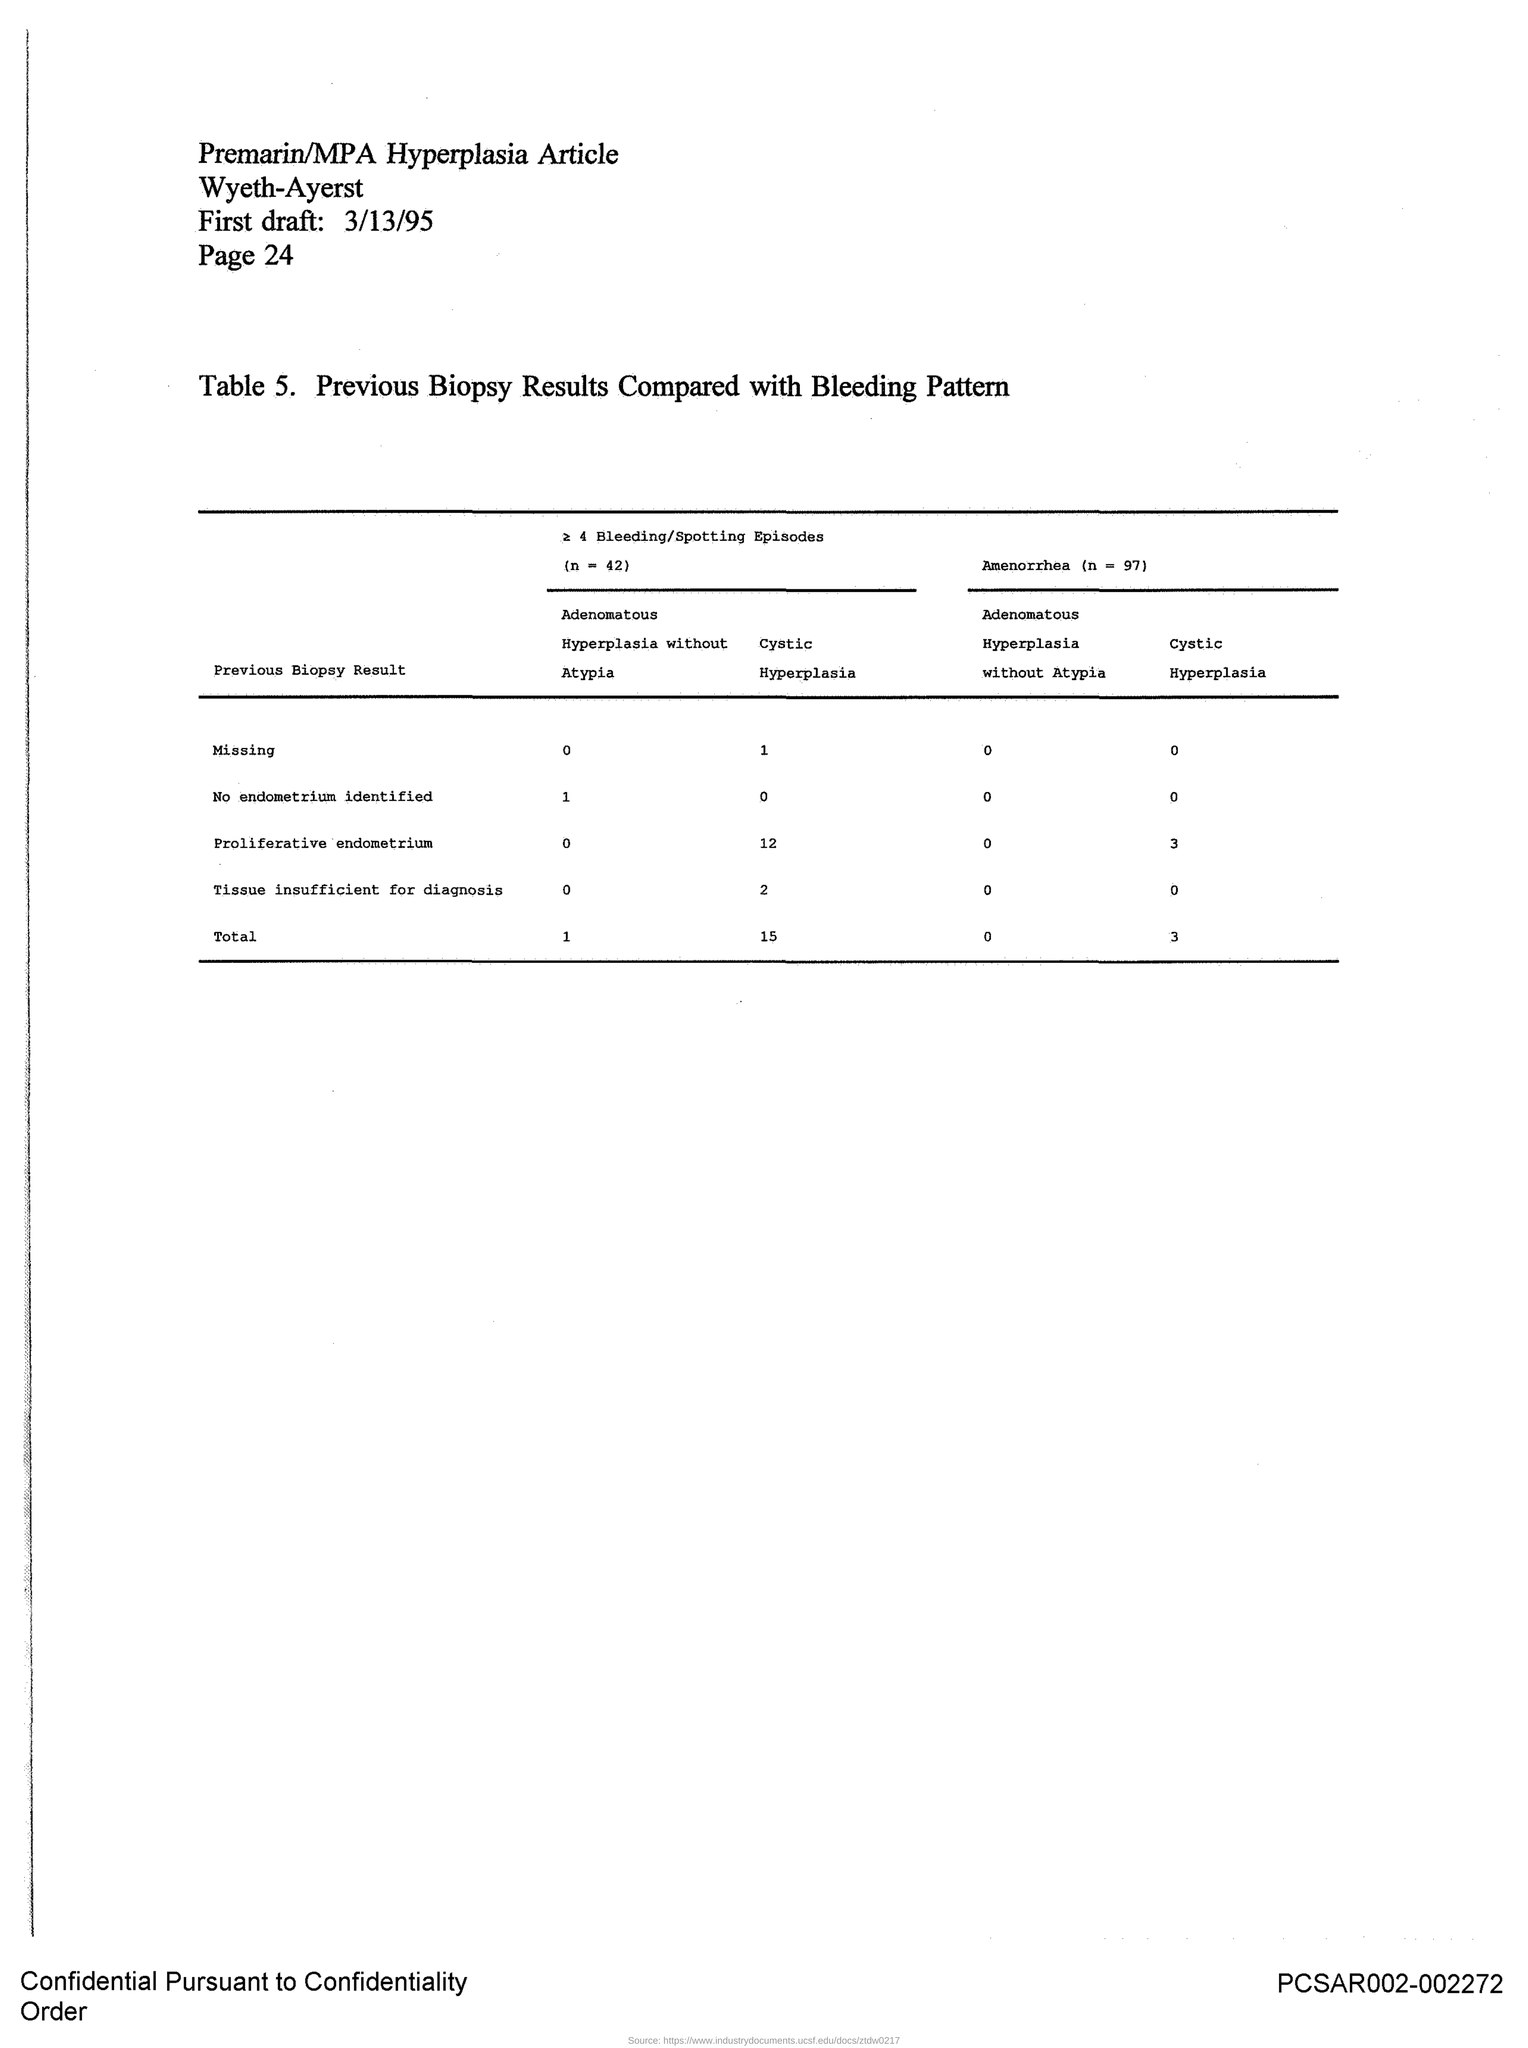Mention a couple of crucial points in this snapshot. The mentioned article in the document is "Premarin/MPA Hyperplasia..". The page number mentioned in this document is 24.. Table 5 provides a description of the comparison between previous biopsy results and bleeding patterns. The first draft date indicated in the document is 3/13/95. 